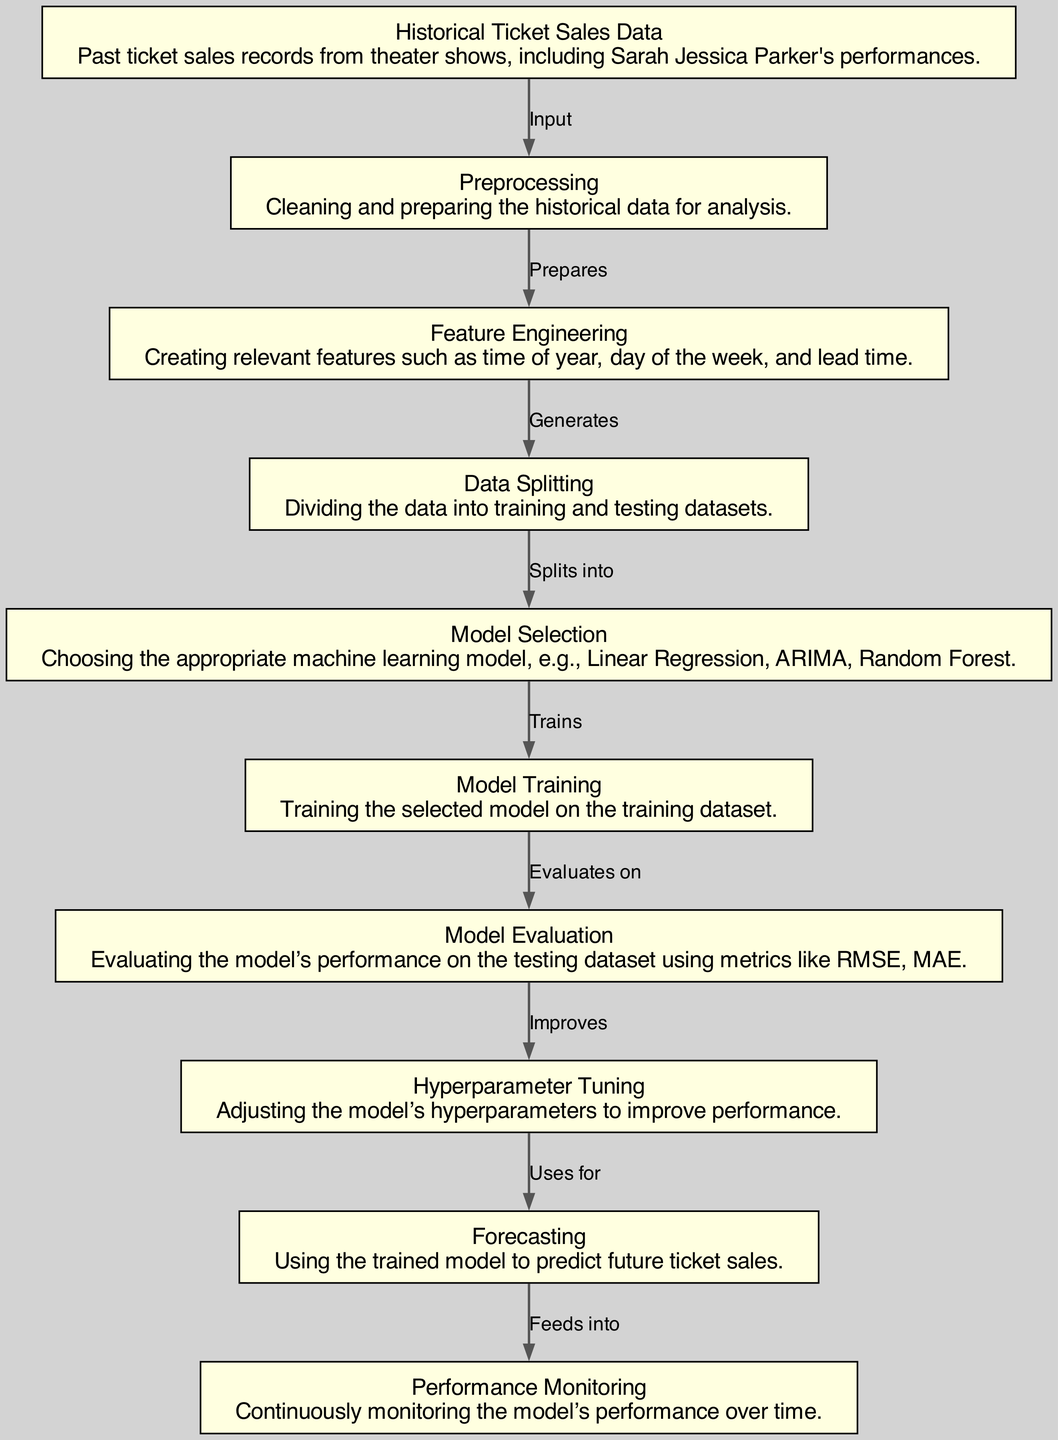What is the first node in the diagram? The first node is "Historical Ticket Sales Data," which represents the collected past ticket sales records for analysis.
Answer: Historical Ticket Sales Data How many nodes are in the diagram? By counting each distinct node from the diagram, we find there are ten nodes representing different stages of the process.
Answer: 10 What connects the "Model Training" node to the "Model Evaluation" node? The edge labeled "Evaluates on" indicates the relationship between "Model Training" and "Model Evaluation."
Answer: Evaluates on What is the last step in the forecasting process? The last node is "Performance Monitoring," which involves tracking the model's performance after forecasting.
Answer: Performance Monitoring Which node comes after "Feature Engineering"? After "Feature Engineering," the next step is "Data Splitting," which involves dividing the dataset into training and testing subsets.
Answer: Data Splitting What type of model might be chosen in the "Model Selection" step? Several models could be selected, including Linear Regression, ARIMA, or Random Forest, as indicated in the description of that node.
Answer: Linear Regression, ARIMA, Random Forest What is the purpose of the "Hyperparameter Tuning" node? This stage is intended to improve model performance by adjusting the hyperparameters of the selected machine learning model.
Answer: Improve performance How does the "Forecasting" node relate to "Hyperparameter Tuning"? The "Forecasting" node uses the model that has undergone hyperparameter tuning to make predictions about future ticket sales.
Answer: Uses for What does the "Preprocessing" node prepare for? The "Preprocessing" node cleans and prepares the historical ticket sales data for further analysis, which is essential for feature extraction.
Answer: Prepares Which step generates the training and testing datasets? The "Data Splitting" node is responsible for generating the training and testing datasets used during model training and evaluation.
Answer: Splits into 